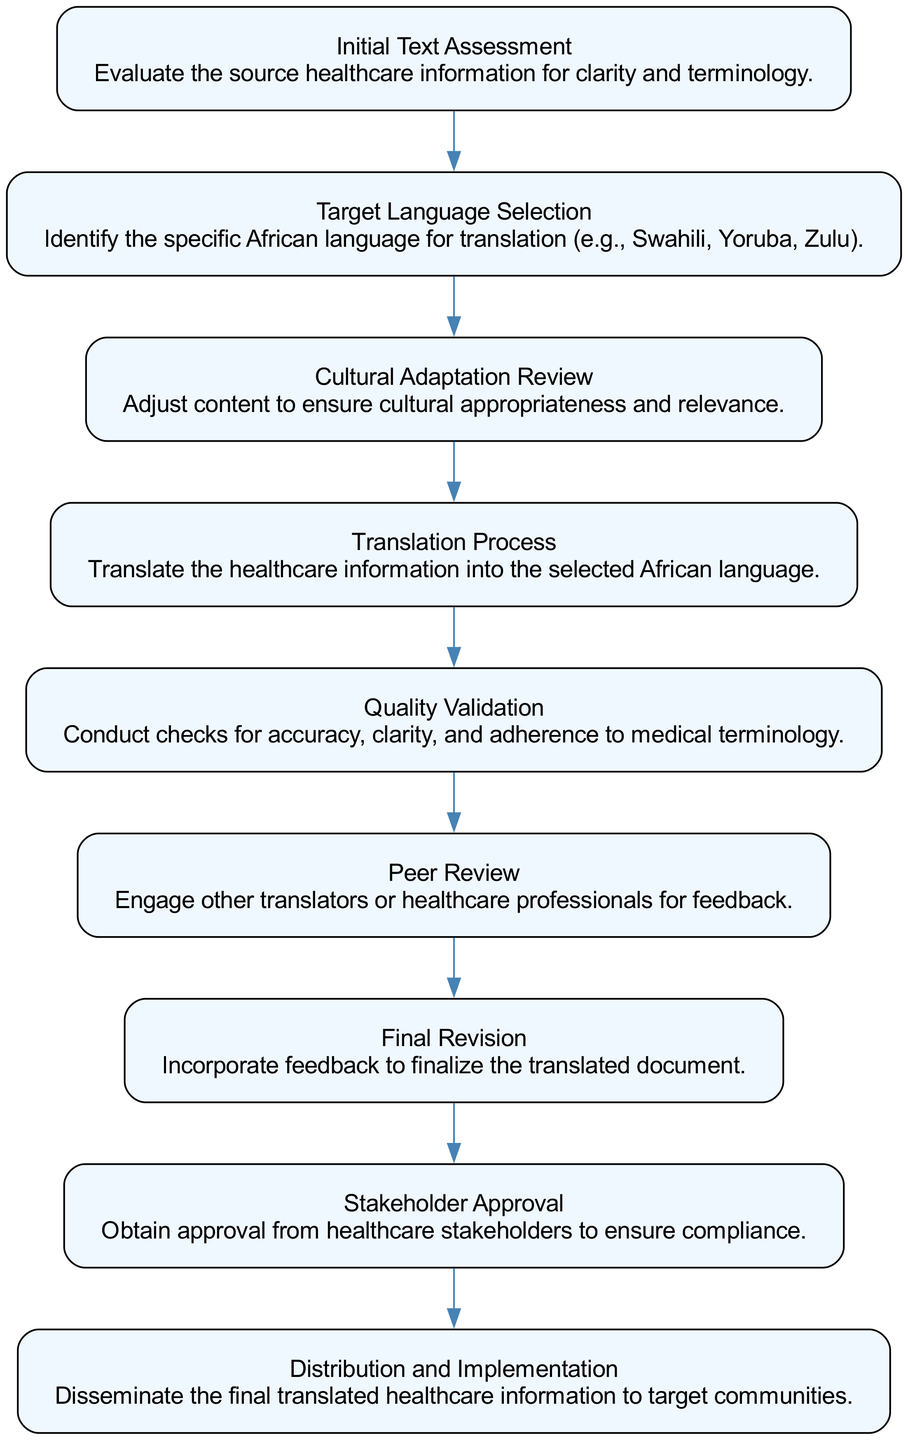What is the first step in the quality assurance procedure? The first step in the flow chart is labeled "Initial Text Assessment," which involves evaluating the source healthcare information for clarity and terminology. This is the starting point of the procedure.
Answer: Initial Text Assessment How many nodes are present in the diagram? By counting the elements listed in the diagram, there are 9 distinct nodes corresponding to each step in the quality assurance procedure.
Answer: 9 What step follows the “Translation Process”? After the "Translation Process" node, the next step in the flow chart is labeled "Quality Validation," which checks the accuracy and clarity of the translated content.
Answer: Quality Validation Which step involves obtaining approval from stakeholders? The step that involves obtaining approval is labeled "Stakeholder Approval," which comes before the distribution of the translated information.
Answer: Stakeholder Approval What connects the "Cultural Adaptation Review" and "Translation Process" nodes? The two nodes are connected by a directed edge that indicates the flow from "Cultural Adaptation Review" to "Translation Process," showing the order in which these steps occur in the procedure.
Answer: Directed edge Which step requires engaging other translators for feedback? The step labeled "Peer Review" necessitates engaging other translators or healthcare professionals to provide feedback on the translation quality.
Answer: Peer Review What is necessary for the final document to be distributed? The final document can only be distributed after obtaining "Stakeholder Approval," indicating that it has been reviewed and authorized by relevant parties.
Answer: Stakeholder Approval What happens after quality validation? After "Quality Validation," the next step is "Peer Review," where the translation is reviewed by others to ensure accuracy and quality.
Answer: Peer Review Describe the flow from "Target Language Selection" to "Translation Process." The flow begins with "Target Language Selection," where the specific language is identified, followed by the "Translation Process," where the healthcare information is actually translated into that selected language. This indicates that selecting a language is essential before translation can occur.
Answer: Select language then translate 